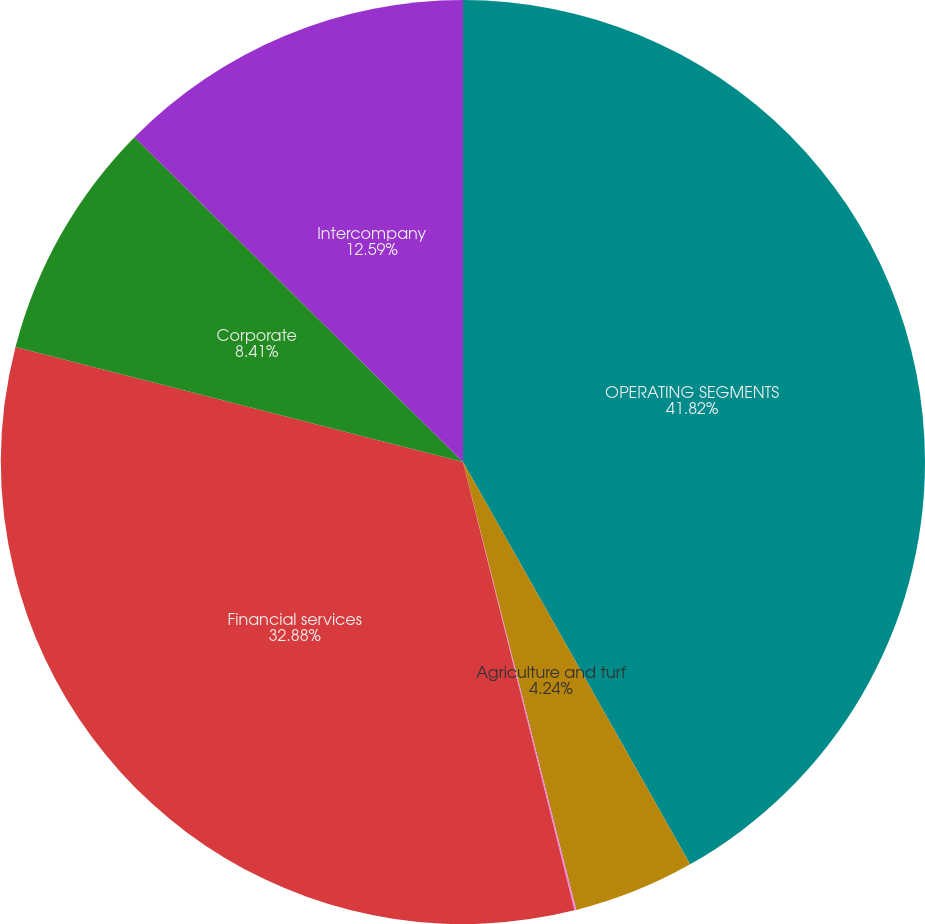Convert chart. <chart><loc_0><loc_0><loc_500><loc_500><pie_chart><fcel>OPERATING SEGMENTS<fcel>Agriculture and turf<fcel>Construction and forestry<fcel>Financial services<fcel>Corporate<fcel>Intercompany<nl><fcel>41.82%<fcel>4.24%<fcel>0.06%<fcel>32.88%<fcel>8.41%<fcel>12.59%<nl></chart> 